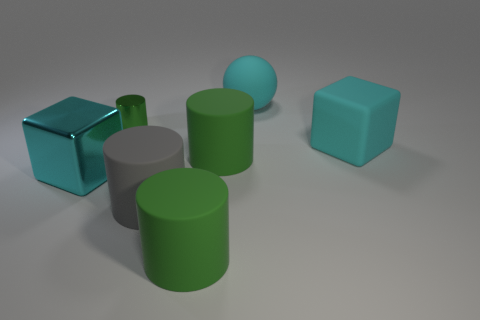There is a cyan object that is in front of the small metal cylinder and to the right of the gray matte cylinder; how big is it?
Your answer should be compact. Large. What number of shiny objects have the same size as the cyan ball?
Your answer should be very brief. 1. What material is the big ball that is the same color as the big rubber cube?
Give a very brief answer. Rubber. Is the shape of the big cyan object that is in front of the big matte cube the same as  the tiny thing?
Keep it short and to the point. No. Is the number of metal cylinders that are right of the cyan rubber ball less than the number of cyan rubber balls?
Your response must be concise. Yes. Is there a large cube of the same color as the big rubber sphere?
Ensure brevity in your answer.  Yes. There is a gray matte thing; is its shape the same as the green rubber thing that is behind the large gray thing?
Your response must be concise. Yes. Is there a gray object made of the same material as the sphere?
Ensure brevity in your answer.  Yes. There is a large matte cylinder that is to the left of the green matte thing that is in front of the cyan metal object; are there any gray matte things that are on the right side of it?
Ensure brevity in your answer.  No. What number of other objects are the same shape as the gray object?
Keep it short and to the point. 3. 